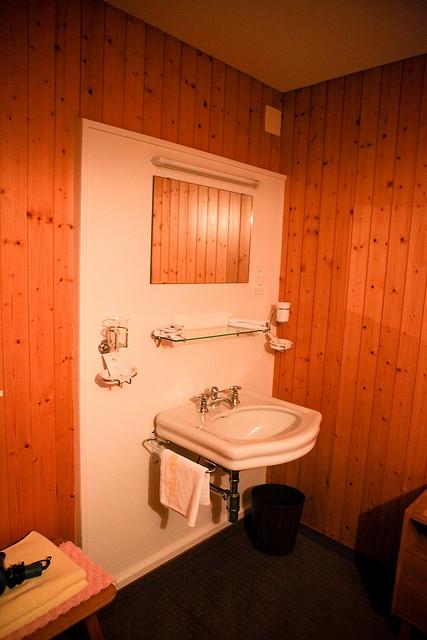What is covering the walls?
Short answer required. Wood paneling. Is there more than one sink?
Write a very short answer. No. What is on the side of the sink?
Answer briefly. Towel. Is this an old-fashioned sink?
Write a very short answer. Yes. What type of paneling is used in this room?
Short answer required. Wood. Is there a toilet in the picture?
Short answer required. No. Is the bathroom likely owned by a man or a woman, or a couple?
Write a very short answer. Man. What type of room is this?
Concise answer only. Bathroom. Where is the sink?
Answer briefly. Bathroom. 